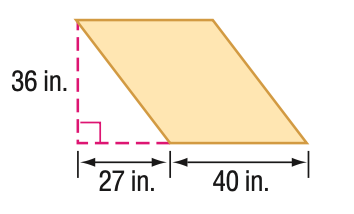Answer the mathemtical geometry problem and directly provide the correct option letter.
Question: Find the perimeter of the parallelogram. Round to the nearest tenth if necessary.
Choices: A: 134 B: 152 C: 170 D: 202 C 